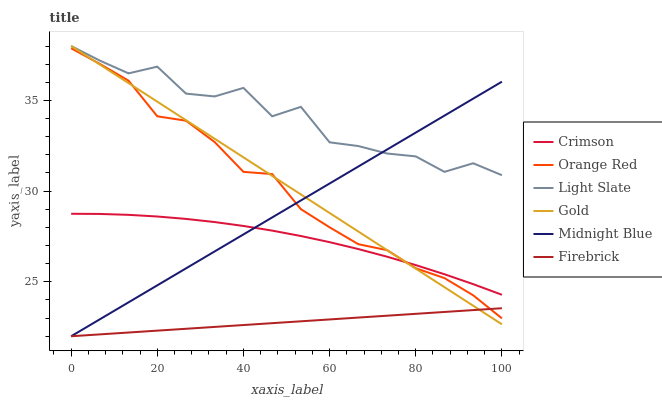Does Firebrick have the minimum area under the curve?
Answer yes or no. Yes. Does Light Slate have the maximum area under the curve?
Answer yes or no. Yes. Does Gold have the minimum area under the curve?
Answer yes or no. No. Does Gold have the maximum area under the curve?
Answer yes or no. No. Is Firebrick the smoothest?
Answer yes or no. Yes. Is Light Slate the roughest?
Answer yes or no. Yes. Is Gold the smoothest?
Answer yes or no. No. Is Gold the roughest?
Answer yes or no. No. Does Midnight Blue have the lowest value?
Answer yes or no. Yes. Does Gold have the lowest value?
Answer yes or no. No. Does Light Slate have the highest value?
Answer yes or no. Yes. Does Firebrick have the highest value?
Answer yes or no. No. Is Orange Red less than Light Slate?
Answer yes or no. Yes. Is Crimson greater than Firebrick?
Answer yes or no. Yes. Does Orange Red intersect Gold?
Answer yes or no. Yes. Is Orange Red less than Gold?
Answer yes or no. No. Is Orange Red greater than Gold?
Answer yes or no. No. Does Orange Red intersect Light Slate?
Answer yes or no. No. 